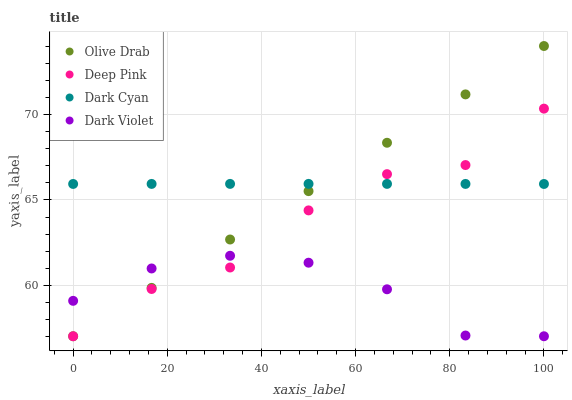Does Dark Violet have the minimum area under the curve?
Answer yes or no. Yes. Does Dark Cyan have the maximum area under the curve?
Answer yes or no. Yes. Does Deep Pink have the minimum area under the curve?
Answer yes or no. No. Does Deep Pink have the maximum area under the curve?
Answer yes or no. No. Is Olive Drab the smoothest?
Answer yes or no. Yes. Is Deep Pink the roughest?
Answer yes or no. Yes. Is Dark Violet the smoothest?
Answer yes or no. No. Is Dark Violet the roughest?
Answer yes or no. No. Does Deep Pink have the lowest value?
Answer yes or no. Yes. Does Olive Drab have the highest value?
Answer yes or no. Yes. Does Deep Pink have the highest value?
Answer yes or no. No. Is Dark Violet less than Dark Cyan?
Answer yes or no. Yes. Is Dark Cyan greater than Dark Violet?
Answer yes or no. Yes. Does Deep Pink intersect Dark Cyan?
Answer yes or no. Yes. Is Deep Pink less than Dark Cyan?
Answer yes or no. No. Is Deep Pink greater than Dark Cyan?
Answer yes or no. No. Does Dark Violet intersect Dark Cyan?
Answer yes or no. No. 